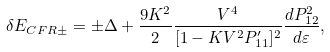Convert formula to latex. <formula><loc_0><loc_0><loc_500><loc_500>\delta E _ { C F R \pm } = \pm \Delta + \frac { 9 K ^ { 2 } } { 2 } \frac { V ^ { 4 } } { [ 1 - K V ^ { 2 } P _ { 1 1 } ^ { \prime } ] ^ { 2 } } \frac { d P _ { 1 2 } ^ { 2 } } { d \varepsilon } ,</formula> 